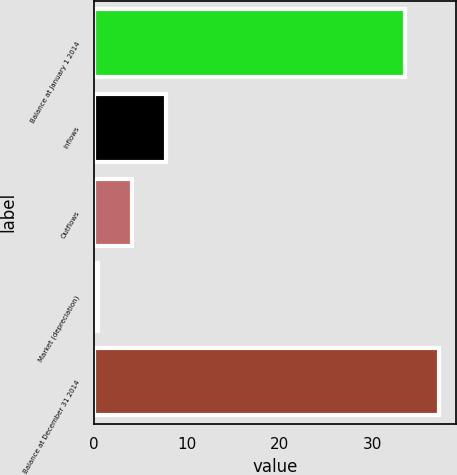<chart> <loc_0><loc_0><loc_500><loc_500><bar_chart><fcel>Balance at January 1 2014<fcel>Inflows<fcel>Outflows<fcel>Market (depreciation)<fcel>Balance at December 31 2014<nl><fcel>33.5<fcel>7.72<fcel>4.06<fcel>0.4<fcel>37.16<nl></chart> 